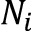Convert formula to latex. <formula><loc_0><loc_0><loc_500><loc_500>N _ { i }</formula> 